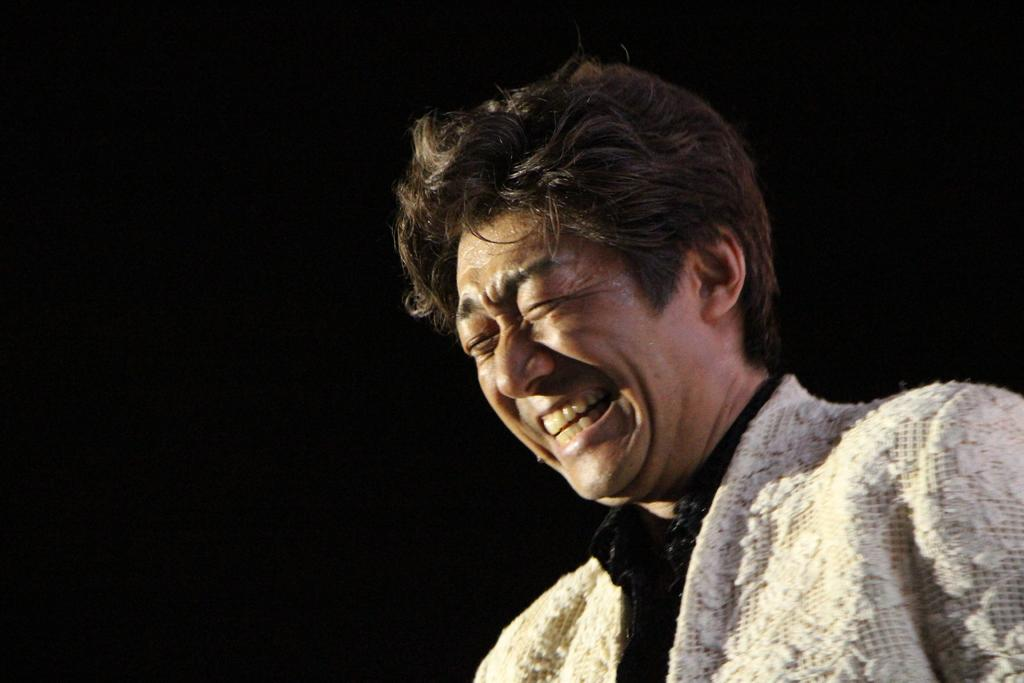What is the main subject of the image? There is a man standing in the image. What is the man wearing on top? The man is wearing a cream sweater. What is the man wearing underneath the sweater? The man is wearing a black shirt. What can be seen behind the man in the image? The backdrop of the image is dark. What type of ship can be seen in the image? There is no ship present in the image; it features a man standing with a dark backdrop. 